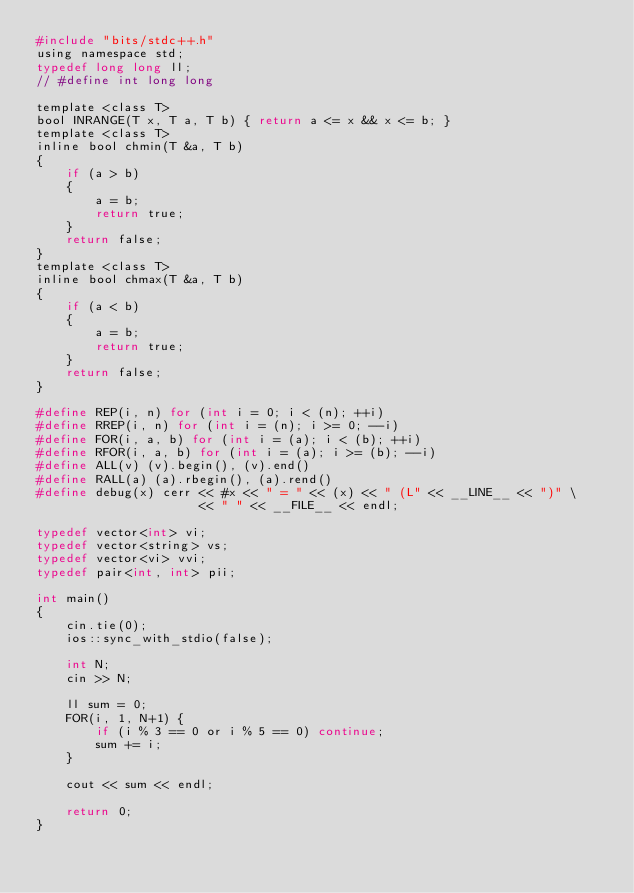<code> <loc_0><loc_0><loc_500><loc_500><_C_>#include "bits/stdc++.h"
using namespace std;
typedef long long ll;
// #define int long long

template <class T>
bool INRANGE(T x, T a, T b) { return a <= x && x <= b; }
template <class T>
inline bool chmin(T &a, T b)
{
    if (a > b)
    {
        a = b;
        return true;
    }
    return false;
}
template <class T>
inline bool chmax(T &a, T b)
{
    if (a < b)
    {
        a = b;
        return true;
    }
    return false;
}

#define REP(i, n) for (int i = 0; i < (n); ++i)
#define RREP(i, n) for (int i = (n); i >= 0; --i)
#define FOR(i, a, b) for (int i = (a); i < (b); ++i)
#define RFOR(i, a, b) for (int i = (a); i >= (b); --i)
#define ALL(v) (v).begin(), (v).end()
#define RALL(a) (a).rbegin(), (a).rend()
#define debug(x) cerr << #x << " = " << (x) << " (L" << __LINE__ << ")" \
                      << " " << __FILE__ << endl;

typedef vector<int> vi;
typedef vector<string> vs;
typedef vector<vi> vvi;
typedef pair<int, int> pii;

int main()
{
    cin.tie(0);
    ios::sync_with_stdio(false);

    int N;
    cin >> N;

    ll sum = 0;
    FOR(i, 1, N+1) {
        if (i % 3 == 0 or i % 5 == 0) continue;
        sum += i;
    }

    cout << sum << endl;

    return 0;
}
</code> 